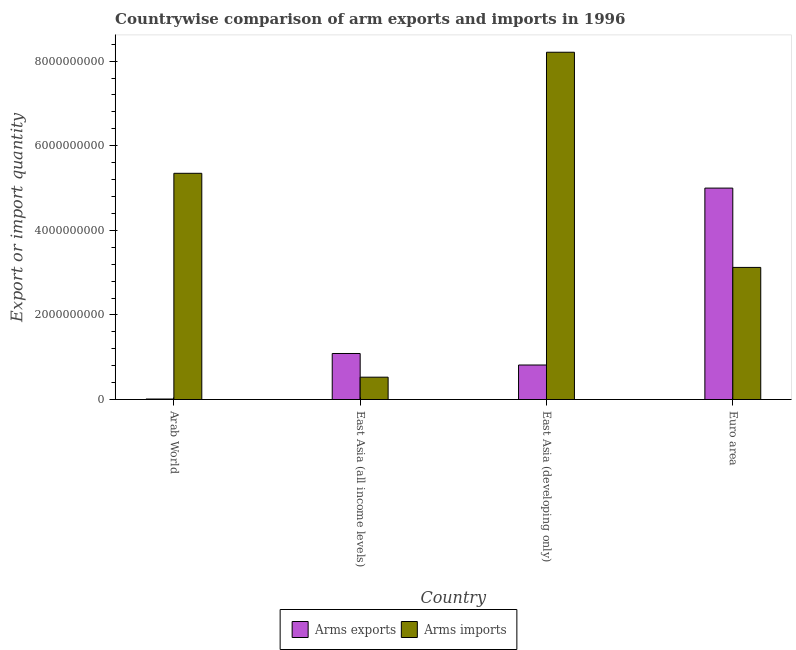Are the number of bars per tick equal to the number of legend labels?
Offer a terse response. Yes. How many bars are there on the 1st tick from the left?
Make the answer very short. 2. How many bars are there on the 3rd tick from the right?
Make the answer very short. 2. What is the arms exports in Euro area?
Provide a short and direct response. 5.00e+09. Across all countries, what is the maximum arms exports?
Make the answer very short. 5.00e+09. Across all countries, what is the minimum arms imports?
Your answer should be compact. 5.28e+08. In which country was the arms exports minimum?
Keep it short and to the point. Arab World. What is the total arms exports in the graph?
Offer a terse response. 6.91e+09. What is the difference between the arms exports in East Asia (all income levels) and that in Euro area?
Ensure brevity in your answer.  -3.91e+09. What is the difference between the arms exports in East Asia (developing only) and the arms imports in East Asia (all income levels)?
Provide a succinct answer. 2.88e+08. What is the average arms exports per country?
Keep it short and to the point. 1.73e+09. What is the difference between the arms exports and arms imports in Arab World?
Offer a terse response. -5.34e+09. In how many countries, is the arms imports greater than 400000000 ?
Offer a terse response. 4. What is the ratio of the arms imports in East Asia (all income levels) to that in Euro area?
Provide a succinct answer. 0.17. Is the difference between the arms exports in Arab World and East Asia (developing only) greater than the difference between the arms imports in Arab World and East Asia (developing only)?
Your answer should be compact. Yes. What is the difference between the highest and the second highest arms imports?
Your answer should be very brief. 2.86e+09. What is the difference between the highest and the lowest arms imports?
Give a very brief answer. 7.68e+09. In how many countries, is the arms exports greater than the average arms exports taken over all countries?
Provide a short and direct response. 1. What does the 2nd bar from the left in Arab World represents?
Provide a succinct answer. Arms imports. What does the 2nd bar from the right in East Asia (all income levels) represents?
Give a very brief answer. Arms exports. How many bars are there?
Your answer should be very brief. 8. Are all the bars in the graph horizontal?
Ensure brevity in your answer.  No. What is the difference between two consecutive major ticks on the Y-axis?
Offer a terse response. 2.00e+09. Does the graph contain any zero values?
Make the answer very short. No. Where does the legend appear in the graph?
Your answer should be compact. Bottom center. How many legend labels are there?
Make the answer very short. 2. How are the legend labels stacked?
Offer a terse response. Horizontal. What is the title of the graph?
Give a very brief answer. Countrywise comparison of arm exports and imports in 1996. What is the label or title of the X-axis?
Ensure brevity in your answer.  Country. What is the label or title of the Y-axis?
Your answer should be compact. Export or import quantity. What is the Export or import quantity of Arms exports in Arab World?
Your response must be concise. 1.20e+07. What is the Export or import quantity in Arms imports in Arab World?
Provide a short and direct response. 5.35e+09. What is the Export or import quantity in Arms exports in East Asia (all income levels)?
Give a very brief answer. 1.09e+09. What is the Export or import quantity in Arms imports in East Asia (all income levels)?
Your response must be concise. 5.28e+08. What is the Export or import quantity in Arms exports in East Asia (developing only)?
Offer a very short reply. 8.16e+08. What is the Export or import quantity of Arms imports in East Asia (developing only)?
Ensure brevity in your answer.  8.21e+09. What is the Export or import quantity of Arms exports in Euro area?
Provide a short and direct response. 5.00e+09. What is the Export or import quantity of Arms imports in Euro area?
Keep it short and to the point. 3.12e+09. Across all countries, what is the maximum Export or import quantity in Arms exports?
Ensure brevity in your answer.  5.00e+09. Across all countries, what is the maximum Export or import quantity in Arms imports?
Offer a very short reply. 8.21e+09. Across all countries, what is the minimum Export or import quantity of Arms imports?
Offer a terse response. 5.28e+08. What is the total Export or import quantity of Arms exports in the graph?
Ensure brevity in your answer.  6.91e+09. What is the total Export or import quantity of Arms imports in the graph?
Offer a very short reply. 1.72e+1. What is the difference between the Export or import quantity in Arms exports in Arab World and that in East Asia (all income levels)?
Make the answer very short. -1.08e+09. What is the difference between the Export or import quantity of Arms imports in Arab World and that in East Asia (all income levels)?
Make the answer very short. 4.82e+09. What is the difference between the Export or import quantity of Arms exports in Arab World and that in East Asia (developing only)?
Provide a succinct answer. -8.04e+08. What is the difference between the Export or import quantity in Arms imports in Arab World and that in East Asia (developing only)?
Ensure brevity in your answer.  -2.86e+09. What is the difference between the Export or import quantity in Arms exports in Arab World and that in Euro area?
Provide a short and direct response. -4.99e+09. What is the difference between the Export or import quantity of Arms imports in Arab World and that in Euro area?
Ensure brevity in your answer.  2.22e+09. What is the difference between the Export or import quantity in Arms exports in East Asia (all income levels) and that in East Asia (developing only)?
Your answer should be compact. 2.72e+08. What is the difference between the Export or import quantity of Arms imports in East Asia (all income levels) and that in East Asia (developing only)?
Give a very brief answer. -7.68e+09. What is the difference between the Export or import quantity of Arms exports in East Asia (all income levels) and that in Euro area?
Provide a succinct answer. -3.91e+09. What is the difference between the Export or import quantity of Arms imports in East Asia (all income levels) and that in Euro area?
Give a very brief answer. -2.60e+09. What is the difference between the Export or import quantity in Arms exports in East Asia (developing only) and that in Euro area?
Your response must be concise. -4.18e+09. What is the difference between the Export or import quantity in Arms imports in East Asia (developing only) and that in Euro area?
Offer a very short reply. 5.09e+09. What is the difference between the Export or import quantity of Arms exports in Arab World and the Export or import quantity of Arms imports in East Asia (all income levels)?
Ensure brevity in your answer.  -5.16e+08. What is the difference between the Export or import quantity of Arms exports in Arab World and the Export or import quantity of Arms imports in East Asia (developing only)?
Keep it short and to the point. -8.20e+09. What is the difference between the Export or import quantity of Arms exports in Arab World and the Export or import quantity of Arms imports in Euro area?
Ensure brevity in your answer.  -3.11e+09. What is the difference between the Export or import quantity in Arms exports in East Asia (all income levels) and the Export or import quantity in Arms imports in East Asia (developing only)?
Your response must be concise. -7.12e+09. What is the difference between the Export or import quantity in Arms exports in East Asia (all income levels) and the Export or import quantity in Arms imports in Euro area?
Keep it short and to the point. -2.04e+09. What is the difference between the Export or import quantity in Arms exports in East Asia (developing only) and the Export or import quantity in Arms imports in Euro area?
Your response must be concise. -2.31e+09. What is the average Export or import quantity of Arms exports per country?
Keep it short and to the point. 1.73e+09. What is the average Export or import quantity of Arms imports per country?
Keep it short and to the point. 4.30e+09. What is the difference between the Export or import quantity of Arms exports and Export or import quantity of Arms imports in Arab World?
Your answer should be compact. -5.34e+09. What is the difference between the Export or import quantity of Arms exports and Export or import quantity of Arms imports in East Asia (all income levels)?
Your answer should be compact. 5.60e+08. What is the difference between the Export or import quantity of Arms exports and Export or import quantity of Arms imports in East Asia (developing only)?
Offer a terse response. -7.39e+09. What is the difference between the Export or import quantity of Arms exports and Export or import quantity of Arms imports in Euro area?
Your response must be concise. 1.88e+09. What is the ratio of the Export or import quantity in Arms exports in Arab World to that in East Asia (all income levels)?
Your response must be concise. 0.01. What is the ratio of the Export or import quantity of Arms imports in Arab World to that in East Asia (all income levels)?
Keep it short and to the point. 10.13. What is the ratio of the Export or import quantity in Arms exports in Arab World to that in East Asia (developing only)?
Provide a succinct answer. 0.01. What is the ratio of the Export or import quantity of Arms imports in Arab World to that in East Asia (developing only)?
Your answer should be compact. 0.65. What is the ratio of the Export or import quantity of Arms exports in Arab World to that in Euro area?
Offer a very short reply. 0. What is the ratio of the Export or import quantity of Arms imports in Arab World to that in Euro area?
Your answer should be compact. 1.71. What is the ratio of the Export or import quantity of Arms exports in East Asia (all income levels) to that in East Asia (developing only)?
Offer a terse response. 1.33. What is the ratio of the Export or import quantity in Arms imports in East Asia (all income levels) to that in East Asia (developing only)?
Provide a succinct answer. 0.06. What is the ratio of the Export or import quantity of Arms exports in East Asia (all income levels) to that in Euro area?
Keep it short and to the point. 0.22. What is the ratio of the Export or import quantity of Arms imports in East Asia (all income levels) to that in Euro area?
Provide a short and direct response. 0.17. What is the ratio of the Export or import quantity in Arms exports in East Asia (developing only) to that in Euro area?
Your response must be concise. 0.16. What is the ratio of the Export or import quantity in Arms imports in East Asia (developing only) to that in Euro area?
Ensure brevity in your answer.  2.63. What is the difference between the highest and the second highest Export or import quantity of Arms exports?
Give a very brief answer. 3.91e+09. What is the difference between the highest and the second highest Export or import quantity in Arms imports?
Keep it short and to the point. 2.86e+09. What is the difference between the highest and the lowest Export or import quantity in Arms exports?
Your answer should be very brief. 4.99e+09. What is the difference between the highest and the lowest Export or import quantity in Arms imports?
Make the answer very short. 7.68e+09. 